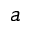Convert formula to latex. <formula><loc_0><loc_0><loc_500><loc_500>a</formula> 